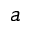Convert formula to latex. <formula><loc_0><loc_0><loc_500><loc_500>a</formula> 